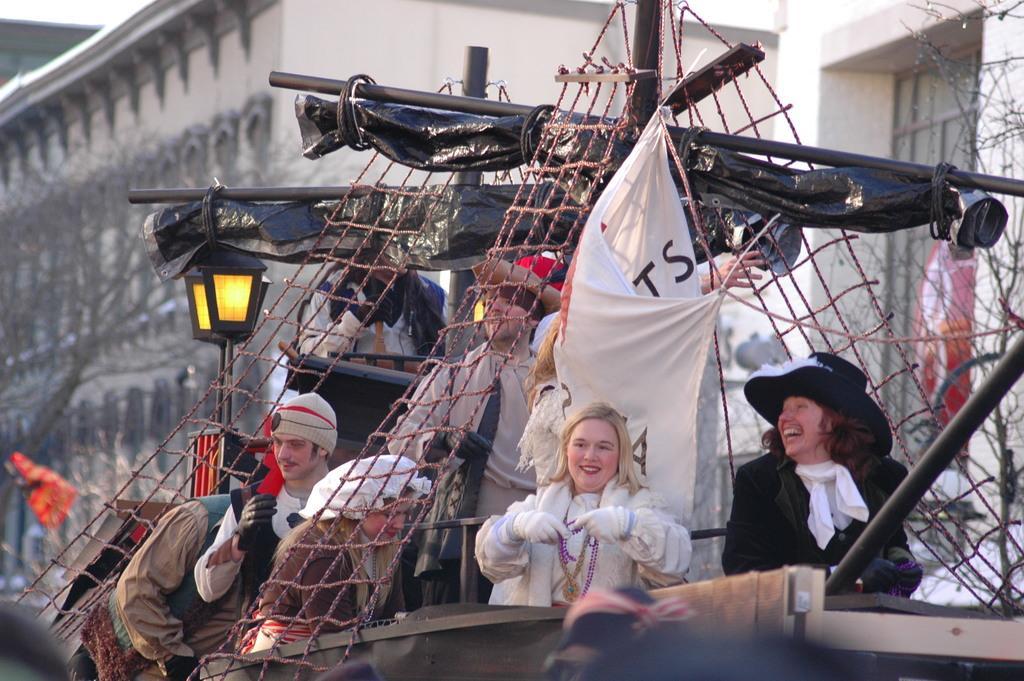Please provide a concise description of this image. In the middle of the image few people are standing in a vehicle. Behind them we can see some trees, poles and buildings. 